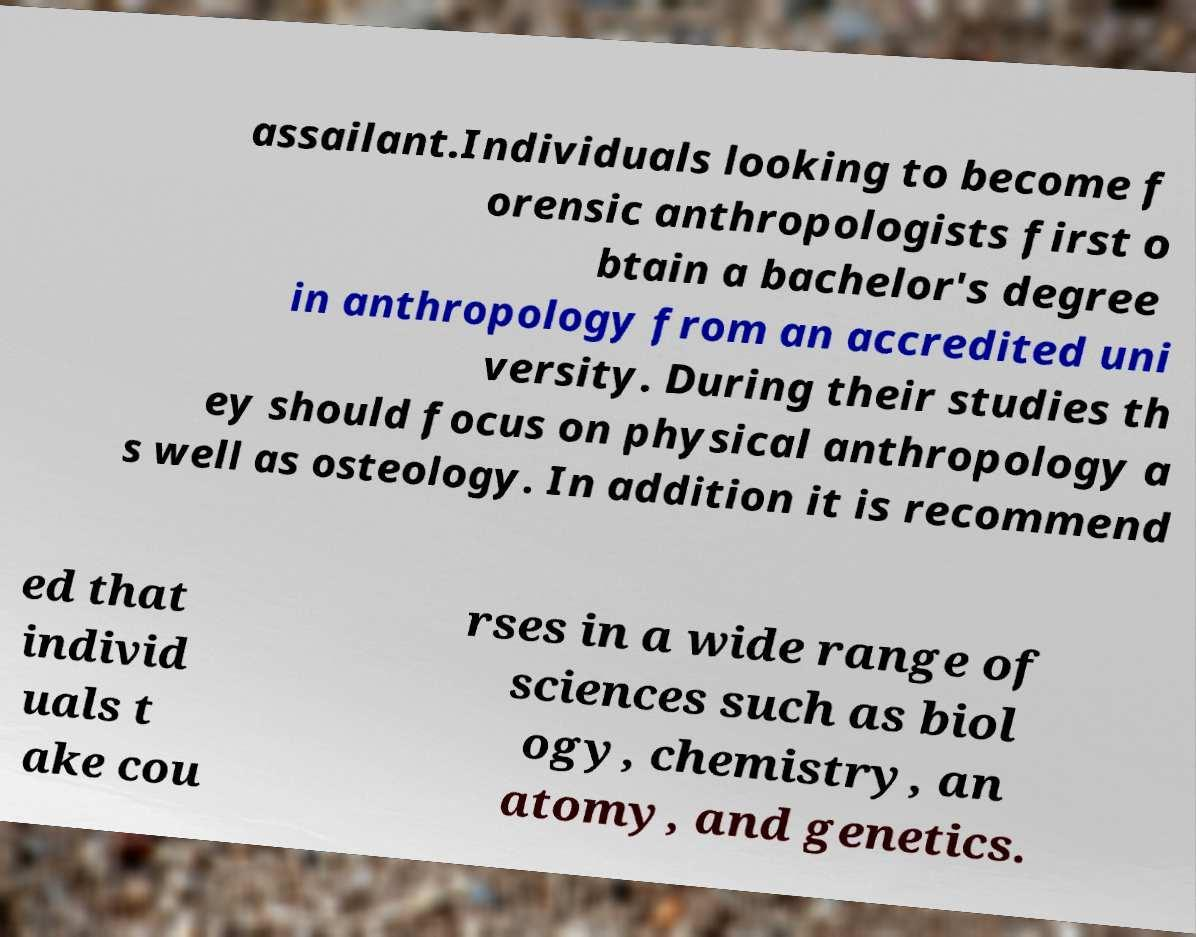Can you accurately transcribe the text from the provided image for me? assailant.Individuals looking to become f orensic anthropologists first o btain a bachelor's degree in anthropology from an accredited uni versity. During their studies th ey should focus on physical anthropology a s well as osteology. In addition it is recommend ed that individ uals t ake cou rses in a wide range of sciences such as biol ogy, chemistry, an atomy, and genetics. 